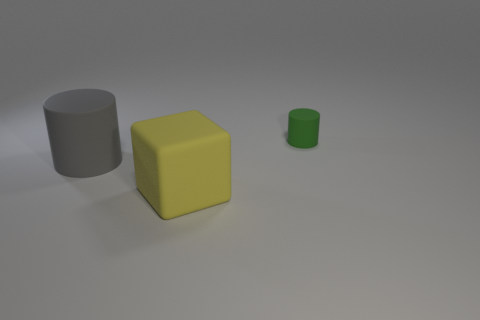Do the cylinder that is in front of the small object and the large block have the same material?
Your response must be concise. Yes. How many green rubber things are the same size as the gray matte thing?
Offer a terse response. 0. Is the number of tiny green rubber objects that are behind the gray thing greater than the number of green things that are behind the big yellow rubber thing?
Your answer should be very brief. No. Is there another tiny green rubber thing that has the same shape as the tiny green rubber object?
Keep it short and to the point. No. There is a cylinder that is behind the large thing behind the big yellow block; what size is it?
Keep it short and to the point. Small. There is a big thing that is behind the big thing that is in front of the rubber cylinder that is to the left of the green rubber cylinder; what is its shape?
Keep it short and to the point. Cylinder. There is a gray object that is made of the same material as the tiny green thing; what is its size?
Make the answer very short. Large. Is the number of big rubber cubes greater than the number of green rubber cubes?
Provide a succinct answer. Yes. There is a gray object that is the same size as the rubber cube; what is its material?
Keep it short and to the point. Rubber. There is a rubber cylinder that is to the right of the block; is it the same size as the gray rubber thing?
Offer a very short reply. No. 